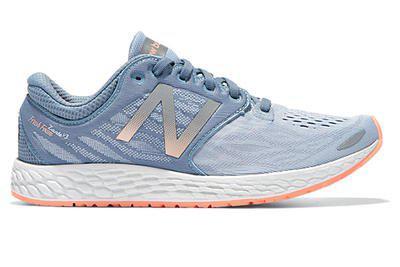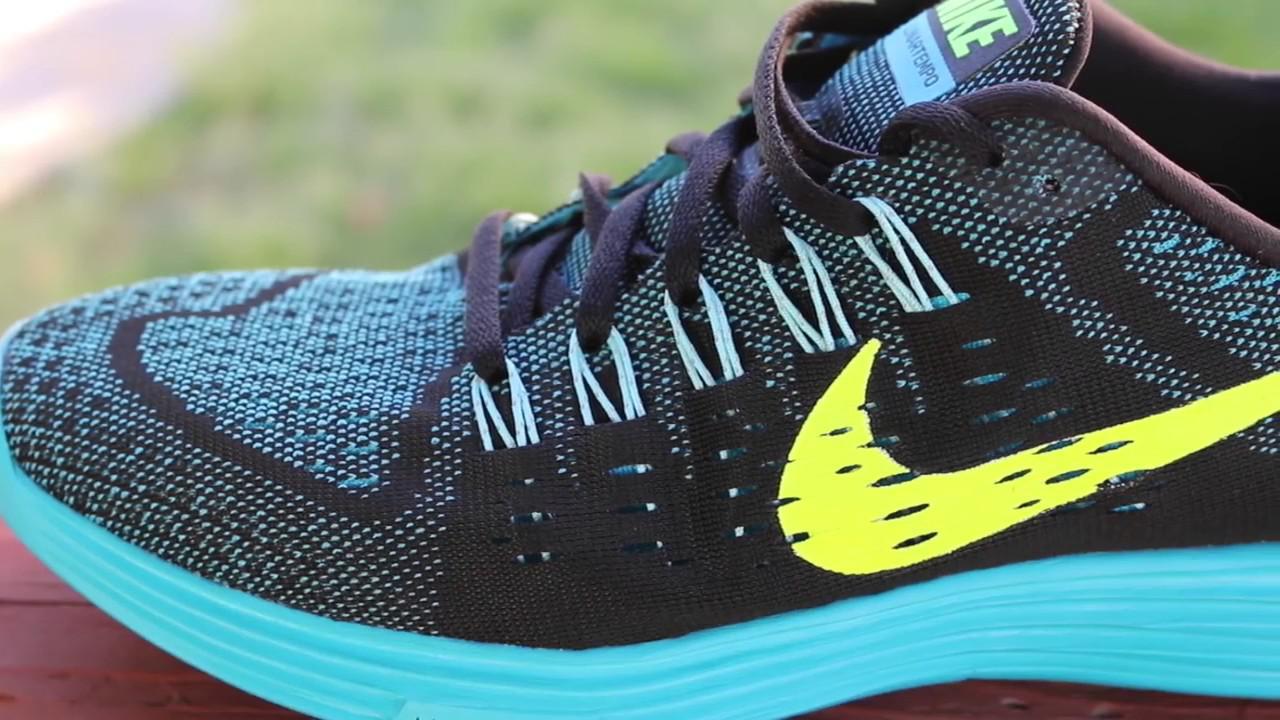The first image is the image on the left, the second image is the image on the right. For the images displayed, is the sentence "No more than four sneakers are shown in total, and one sneaker is shown heel-first." factually correct? Answer yes or no. No. The first image is the image on the left, the second image is the image on the right. Examine the images to the left and right. Is the description "There is a pair of matching shoes in at least one of the images." accurate? Answer yes or no. No. 